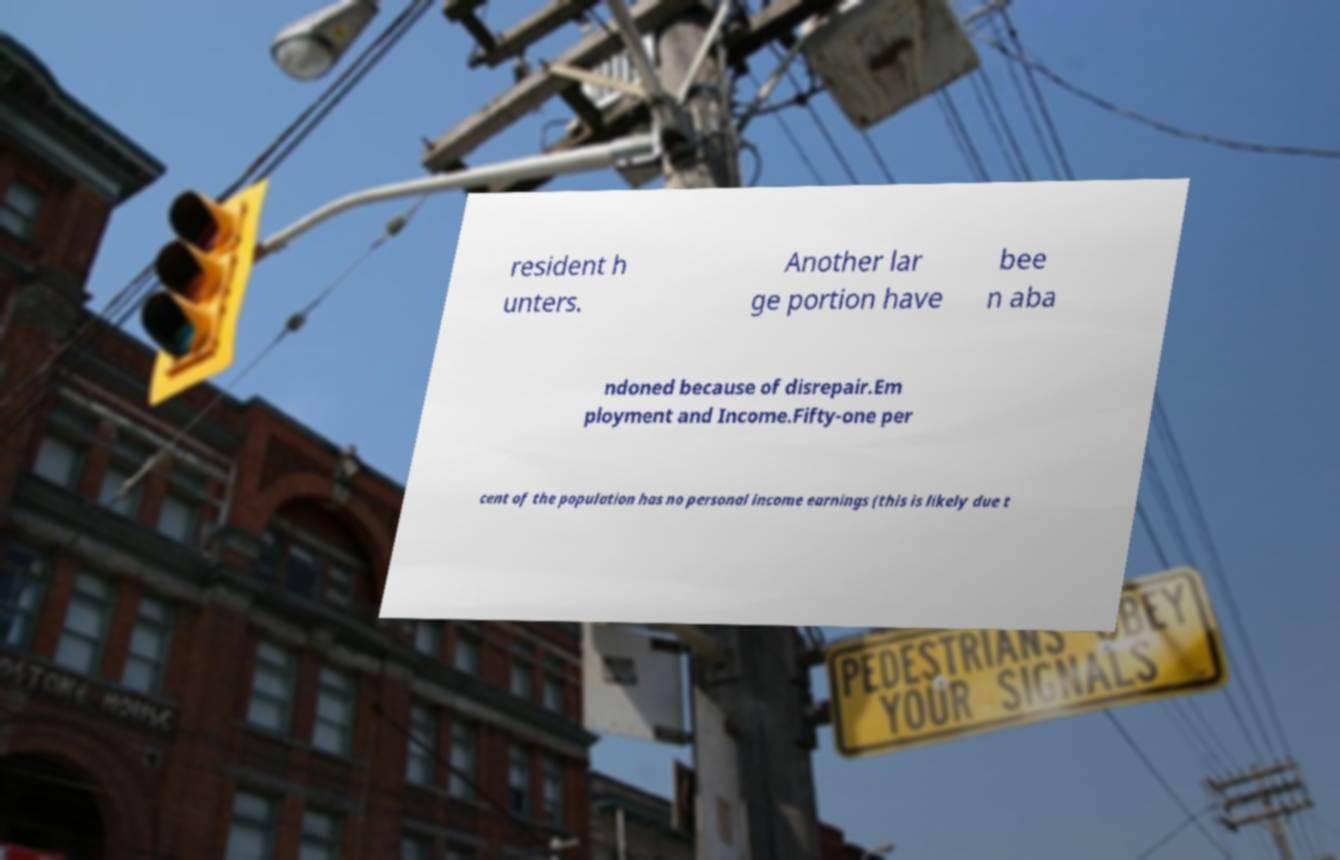For documentation purposes, I need the text within this image transcribed. Could you provide that? resident h unters. Another lar ge portion have bee n aba ndoned because of disrepair.Em ployment and Income.Fifty-one per cent of the population has no personal income earnings (this is likely due t 